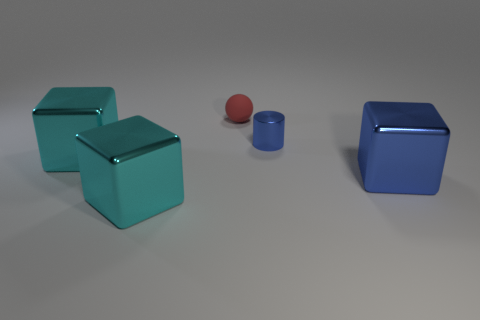Is the number of big blue shiny objects that are behind the tiny shiny thing greater than the number of metal spheres?
Offer a terse response. No. What is the size of the block that is the same color as the tiny metallic cylinder?
Your answer should be compact. Large. Is there another cyan object that has the same shape as the matte object?
Your answer should be compact. No. What number of things are tiny yellow balls or big blue blocks?
Ensure brevity in your answer.  1. How many large shiny cubes are to the left of the tiny red ball left of the large shiny cube that is right of the small blue object?
Your answer should be compact. 2. What is the thing that is both behind the large blue metal object and on the left side of the red rubber ball made of?
Offer a very short reply. Metal. Are there fewer tiny red matte spheres behind the matte object than red balls in front of the small blue cylinder?
Offer a very short reply. No. How many other objects are there of the same size as the cylinder?
Offer a very short reply. 1. What is the shape of the big thing on the left side of the cyan block that is in front of the blue thing right of the small blue shiny thing?
Offer a terse response. Cube. How many blue objects are either large metallic cubes or tiny cylinders?
Give a very brief answer. 2. 